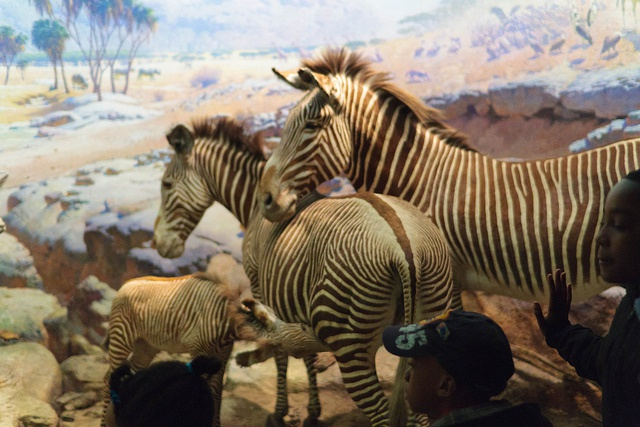Describe the objects in this image and their specific colors. I can see zebra in lightblue, maroon, black, and tan tones, zebra in lightblue, black, olive, and tan tones, zebra in lightblue, olive, and black tones, people in lightblue, black, maroon, and gray tones, and people in lightblue, black, gray, and olive tones in this image. 